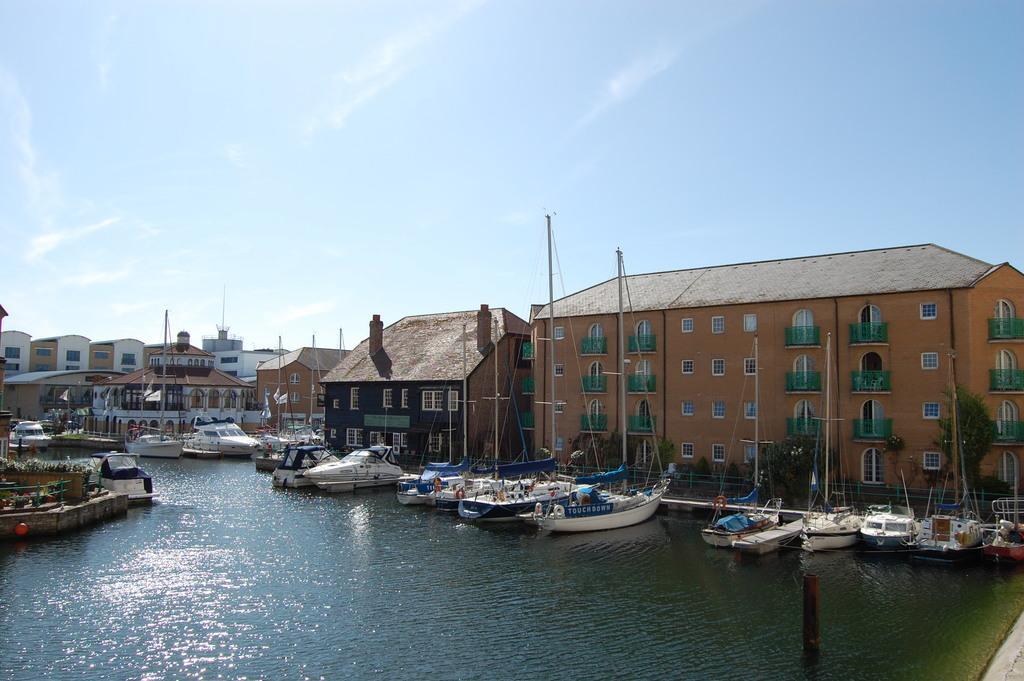Describe this image in one or two sentences. In this image, we can see boats on the sea, and in the background, there are buildings. 